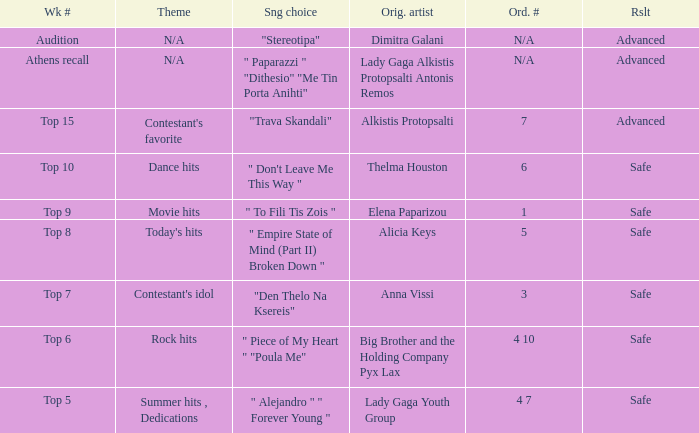What are all the order #s from the week "top 6"? 4 10. 